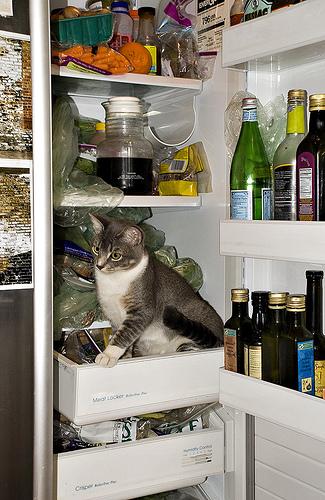What kind of animal is this?
Give a very brief answer. Cat. What's unusual about this photo?
Answer briefly. Cat in fridge. What is the cat sitting in?
Quick response, please. Fridge. 